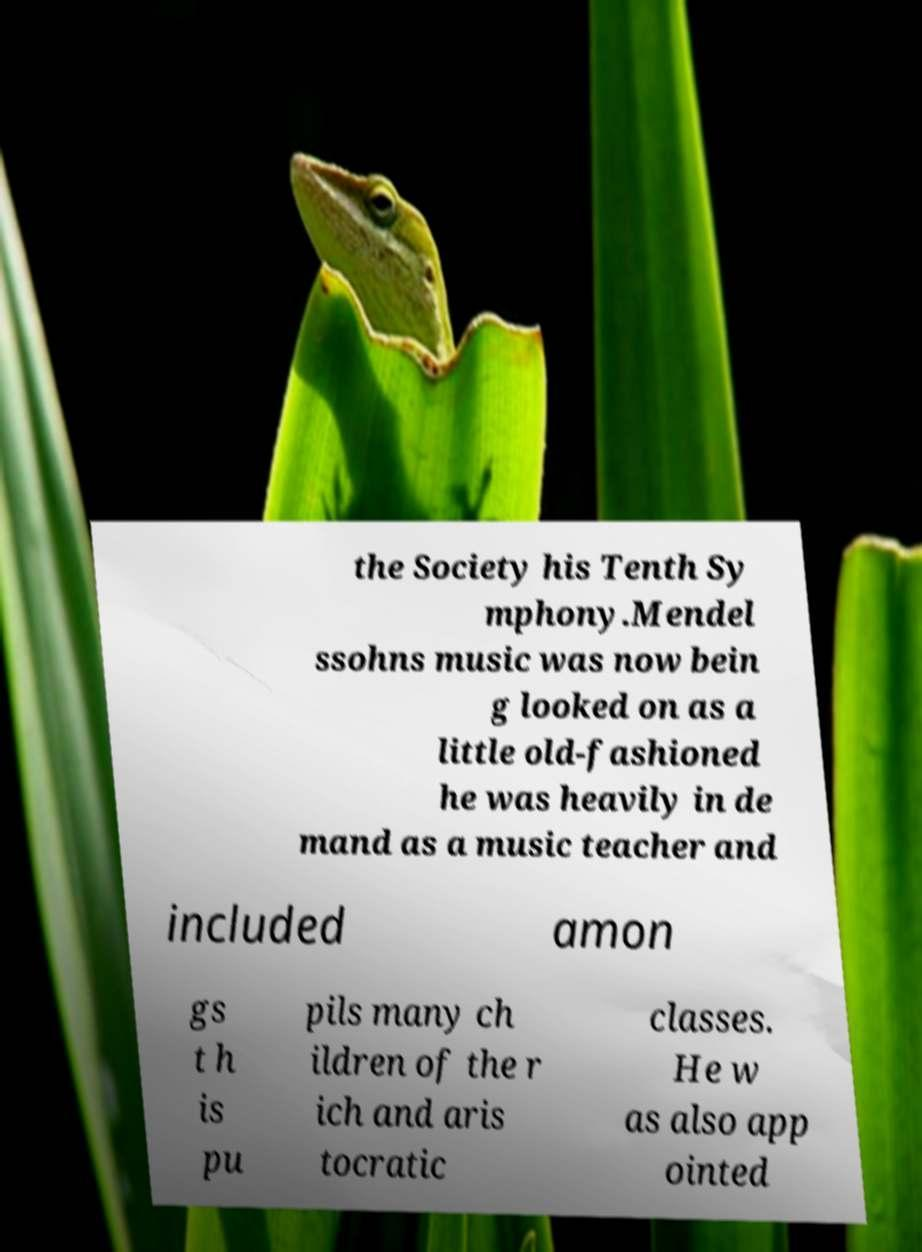I need the written content from this picture converted into text. Can you do that? the Society his Tenth Sy mphony.Mendel ssohns music was now bein g looked on as a little old-fashioned he was heavily in de mand as a music teacher and included amon gs t h is pu pils many ch ildren of the r ich and aris tocratic classes. He w as also app ointed 